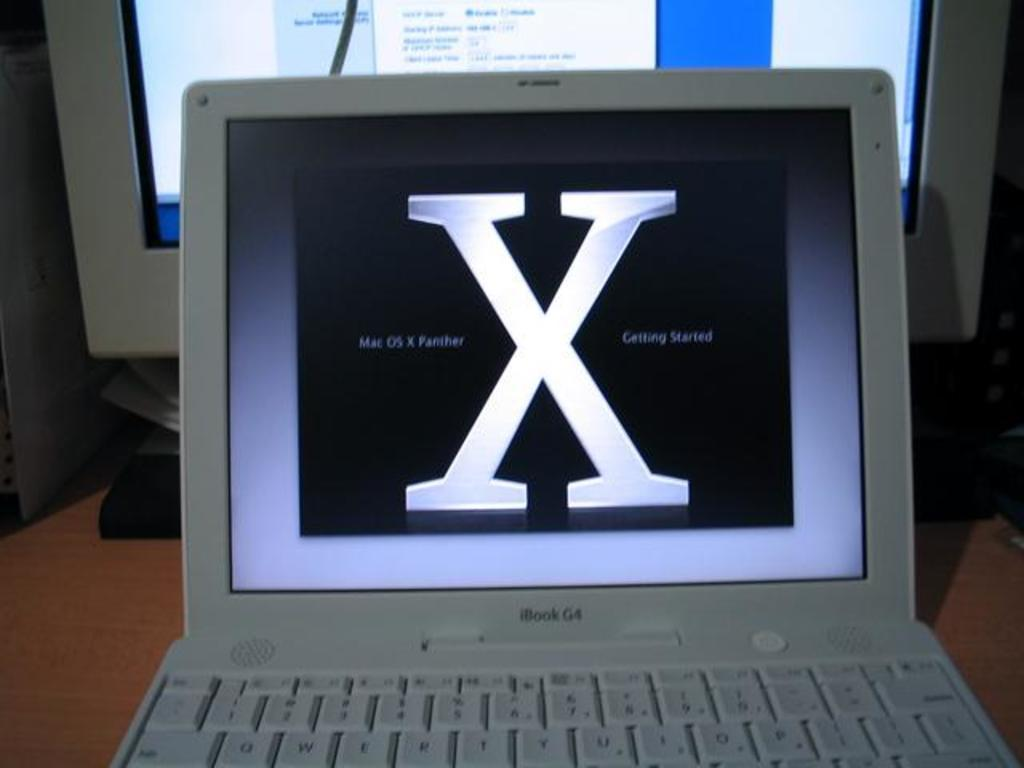<image>
Share a concise interpretation of the image provided. a white ibookgr with a huge white x on the screen 